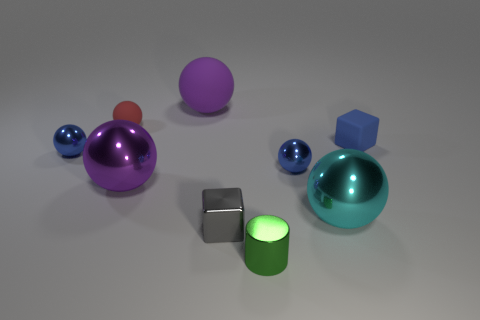Can you describe the arrangement or pattern formed by the objects? The objects are arranged sporadically across the image with no apparent pattern. Their placement appears random, with varying distances between them, and there's no symmetry or obvious geometric arrangement. The sizes of the objects vary as well, and they are not aligned in any particular axis. 